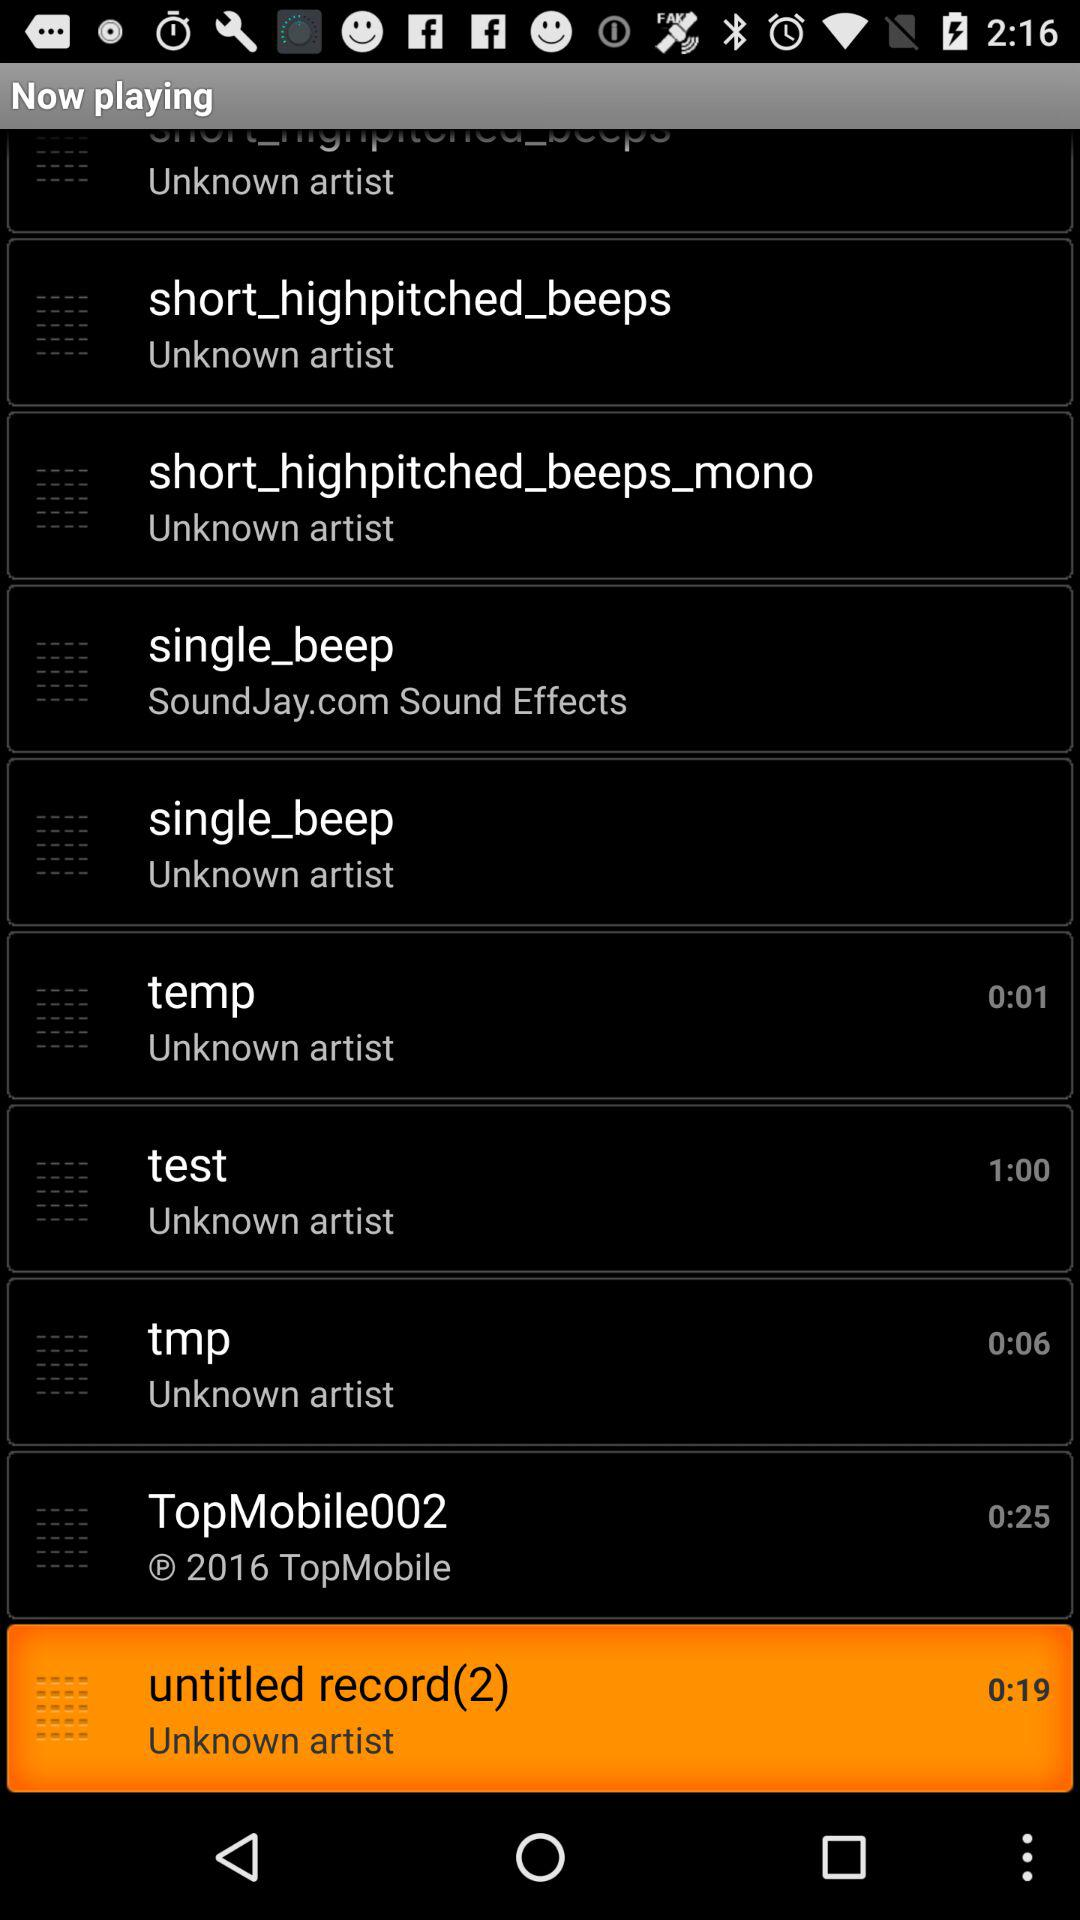How long is the "TopMobile002" audio file? The "TopMobile002" audio file is 25 seconds long. 